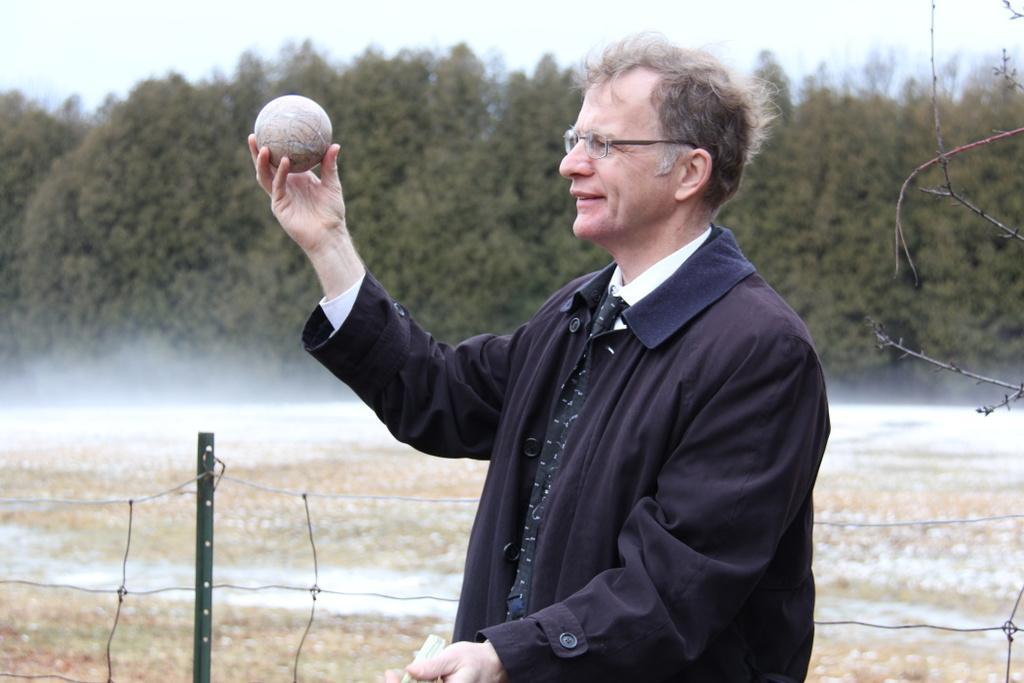Please provide a concise description of this image. In this picture we can see a man holding a ball in his hand. He is standing on the ground surrounded by trees. 